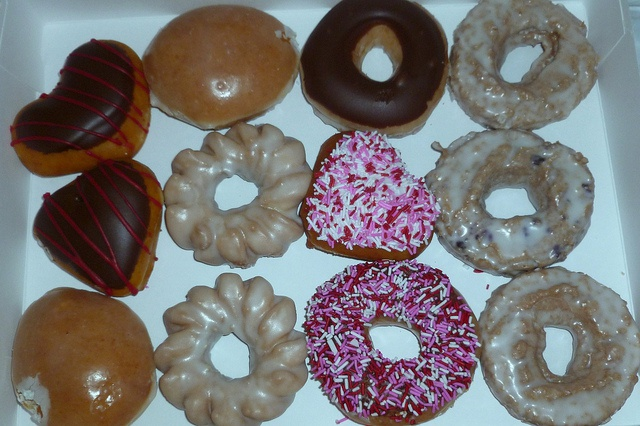Describe the objects in this image and their specific colors. I can see donut in gray, maroon, purple, and lightblue tones, donut in gray and lightblue tones, donut in gray, darkgray, and lightblue tones, donut in gray, darkgray, and lightblue tones, and donut in gray and lightblue tones in this image. 